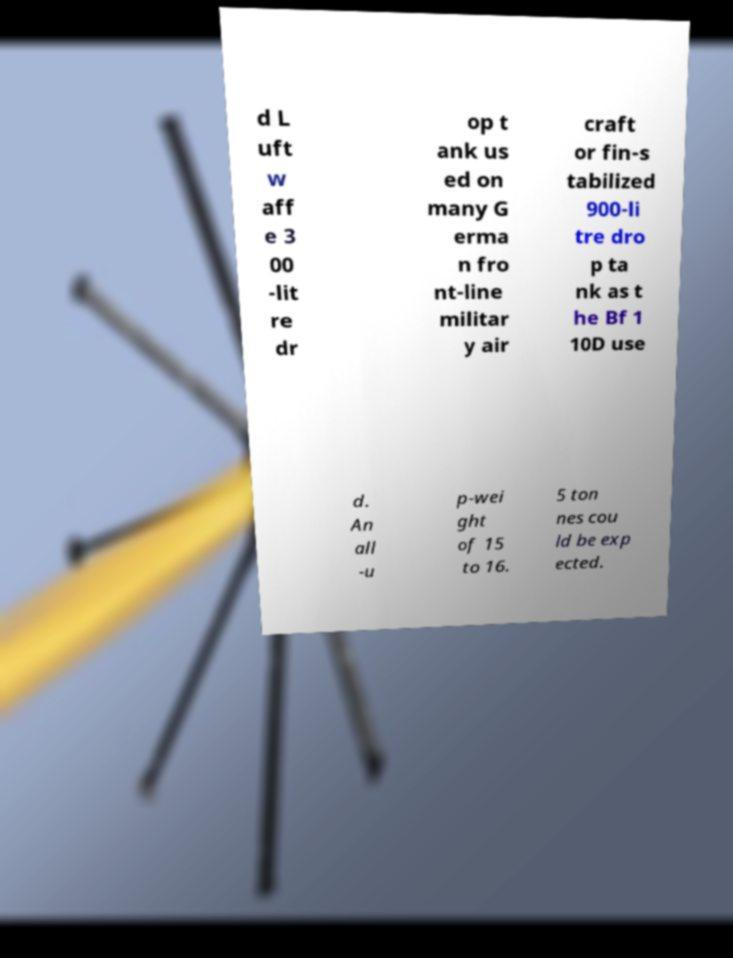For documentation purposes, I need the text within this image transcribed. Could you provide that? d L uft w aff e 3 00 -lit re dr op t ank us ed on many G erma n fro nt-line militar y air craft or fin-s tabilized 900-li tre dro p ta nk as t he Bf 1 10D use d. An all -u p-wei ght of 15 to 16. 5 ton nes cou ld be exp ected. 